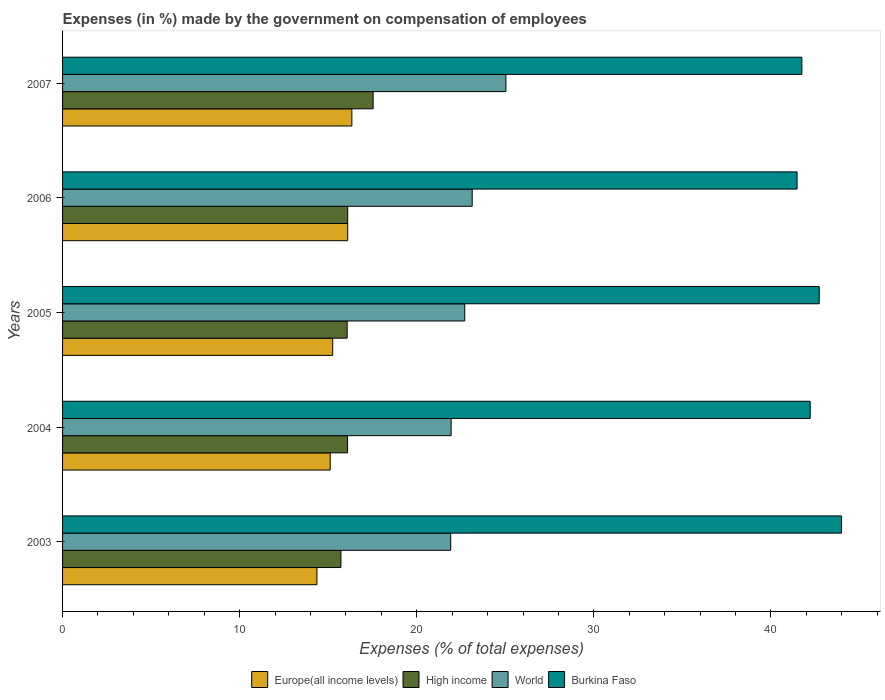Are the number of bars per tick equal to the number of legend labels?
Give a very brief answer. Yes. How many bars are there on the 4th tick from the bottom?
Your response must be concise. 4. What is the percentage of expenses made by the government on compensation of employees in Burkina Faso in 2006?
Provide a short and direct response. 41.47. Across all years, what is the maximum percentage of expenses made by the government on compensation of employees in Europe(all income levels)?
Keep it short and to the point. 16.34. Across all years, what is the minimum percentage of expenses made by the government on compensation of employees in High income?
Provide a short and direct response. 15.72. What is the total percentage of expenses made by the government on compensation of employees in Burkina Faso in the graph?
Provide a succinct answer. 212.14. What is the difference between the percentage of expenses made by the government on compensation of employees in High income in 2005 and that in 2007?
Provide a succinct answer. -1.47. What is the difference between the percentage of expenses made by the government on compensation of employees in High income in 2005 and the percentage of expenses made by the government on compensation of employees in Europe(all income levels) in 2007?
Offer a very short reply. -0.27. What is the average percentage of expenses made by the government on compensation of employees in World per year?
Offer a very short reply. 22.94. In the year 2003, what is the difference between the percentage of expenses made by the government on compensation of employees in Europe(all income levels) and percentage of expenses made by the government on compensation of employees in World?
Provide a succinct answer. -7.55. What is the ratio of the percentage of expenses made by the government on compensation of employees in Burkina Faso in 2003 to that in 2006?
Offer a terse response. 1.06. What is the difference between the highest and the second highest percentage of expenses made by the government on compensation of employees in Europe(all income levels)?
Your answer should be very brief. 0.24. What is the difference between the highest and the lowest percentage of expenses made by the government on compensation of employees in Europe(all income levels)?
Your response must be concise. 1.97. What does the 2nd bar from the top in 2006 represents?
Offer a very short reply. World. What does the 2nd bar from the bottom in 2004 represents?
Your answer should be compact. High income. Is it the case that in every year, the sum of the percentage of expenses made by the government on compensation of employees in World and percentage of expenses made by the government on compensation of employees in Burkina Faso is greater than the percentage of expenses made by the government on compensation of employees in High income?
Provide a short and direct response. Yes. How many bars are there?
Offer a terse response. 20. What is the difference between two consecutive major ticks on the X-axis?
Make the answer very short. 10. Are the values on the major ticks of X-axis written in scientific E-notation?
Your answer should be compact. No. Does the graph contain any zero values?
Offer a very short reply. No. Does the graph contain grids?
Offer a very short reply. No. What is the title of the graph?
Your answer should be compact. Expenses (in %) made by the government on compensation of employees. Does "Sudan" appear as one of the legend labels in the graph?
Make the answer very short. No. What is the label or title of the X-axis?
Your response must be concise. Expenses (% of total expenses). What is the label or title of the Y-axis?
Ensure brevity in your answer.  Years. What is the Expenses (% of total expenses) in Europe(all income levels) in 2003?
Your answer should be compact. 14.36. What is the Expenses (% of total expenses) in High income in 2003?
Your answer should be very brief. 15.72. What is the Expenses (% of total expenses) of World in 2003?
Your answer should be compact. 21.92. What is the Expenses (% of total expenses) in Burkina Faso in 2003?
Offer a very short reply. 43.98. What is the Expenses (% of total expenses) of Europe(all income levels) in 2004?
Keep it short and to the point. 15.11. What is the Expenses (% of total expenses) in High income in 2004?
Provide a succinct answer. 16.09. What is the Expenses (% of total expenses) in World in 2004?
Offer a very short reply. 21.94. What is the Expenses (% of total expenses) in Burkina Faso in 2004?
Provide a succinct answer. 42.21. What is the Expenses (% of total expenses) in Europe(all income levels) in 2005?
Provide a short and direct response. 15.25. What is the Expenses (% of total expenses) of High income in 2005?
Offer a very short reply. 16.07. What is the Expenses (% of total expenses) of World in 2005?
Your answer should be very brief. 22.71. What is the Expenses (% of total expenses) in Burkina Faso in 2005?
Keep it short and to the point. 42.72. What is the Expenses (% of total expenses) in Europe(all income levels) in 2006?
Offer a very short reply. 16.1. What is the Expenses (% of total expenses) in High income in 2006?
Provide a succinct answer. 16.1. What is the Expenses (% of total expenses) in World in 2006?
Your answer should be compact. 23.13. What is the Expenses (% of total expenses) in Burkina Faso in 2006?
Give a very brief answer. 41.47. What is the Expenses (% of total expenses) in Europe(all income levels) in 2007?
Give a very brief answer. 16.34. What is the Expenses (% of total expenses) in High income in 2007?
Provide a succinct answer. 17.54. What is the Expenses (% of total expenses) in World in 2007?
Your answer should be very brief. 25.03. What is the Expenses (% of total expenses) in Burkina Faso in 2007?
Offer a very short reply. 41.74. Across all years, what is the maximum Expenses (% of total expenses) of Europe(all income levels)?
Provide a succinct answer. 16.34. Across all years, what is the maximum Expenses (% of total expenses) of High income?
Give a very brief answer. 17.54. Across all years, what is the maximum Expenses (% of total expenses) of World?
Ensure brevity in your answer.  25.03. Across all years, what is the maximum Expenses (% of total expenses) of Burkina Faso?
Make the answer very short. 43.98. Across all years, what is the minimum Expenses (% of total expenses) of Europe(all income levels)?
Offer a very short reply. 14.36. Across all years, what is the minimum Expenses (% of total expenses) in High income?
Your answer should be very brief. 15.72. Across all years, what is the minimum Expenses (% of total expenses) in World?
Offer a terse response. 21.92. Across all years, what is the minimum Expenses (% of total expenses) of Burkina Faso?
Keep it short and to the point. 41.47. What is the total Expenses (% of total expenses) of Europe(all income levels) in the graph?
Ensure brevity in your answer.  77.16. What is the total Expenses (% of total expenses) of High income in the graph?
Your answer should be very brief. 81.52. What is the total Expenses (% of total expenses) in World in the graph?
Ensure brevity in your answer.  114.72. What is the total Expenses (% of total expenses) in Burkina Faso in the graph?
Offer a very short reply. 212.14. What is the difference between the Expenses (% of total expenses) of Europe(all income levels) in 2003 and that in 2004?
Offer a very short reply. -0.75. What is the difference between the Expenses (% of total expenses) in High income in 2003 and that in 2004?
Your answer should be very brief. -0.37. What is the difference between the Expenses (% of total expenses) in World in 2003 and that in 2004?
Ensure brevity in your answer.  -0.02. What is the difference between the Expenses (% of total expenses) in Burkina Faso in 2003 and that in 2004?
Offer a terse response. 1.77. What is the difference between the Expenses (% of total expenses) of Europe(all income levels) in 2003 and that in 2005?
Offer a very short reply. -0.89. What is the difference between the Expenses (% of total expenses) of High income in 2003 and that in 2005?
Ensure brevity in your answer.  -0.35. What is the difference between the Expenses (% of total expenses) of World in 2003 and that in 2005?
Make the answer very short. -0.79. What is the difference between the Expenses (% of total expenses) of Burkina Faso in 2003 and that in 2005?
Provide a short and direct response. 1.26. What is the difference between the Expenses (% of total expenses) of Europe(all income levels) in 2003 and that in 2006?
Your answer should be compact. -1.74. What is the difference between the Expenses (% of total expenses) in High income in 2003 and that in 2006?
Give a very brief answer. -0.38. What is the difference between the Expenses (% of total expenses) of World in 2003 and that in 2006?
Make the answer very short. -1.21. What is the difference between the Expenses (% of total expenses) of Burkina Faso in 2003 and that in 2006?
Keep it short and to the point. 2.51. What is the difference between the Expenses (% of total expenses) of Europe(all income levels) in 2003 and that in 2007?
Make the answer very short. -1.97. What is the difference between the Expenses (% of total expenses) of High income in 2003 and that in 2007?
Your answer should be compact. -1.82. What is the difference between the Expenses (% of total expenses) in World in 2003 and that in 2007?
Your answer should be very brief. -3.12. What is the difference between the Expenses (% of total expenses) in Burkina Faso in 2003 and that in 2007?
Your answer should be very brief. 2.24. What is the difference between the Expenses (% of total expenses) of Europe(all income levels) in 2004 and that in 2005?
Your response must be concise. -0.14. What is the difference between the Expenses (% of total expenses) in High income in 2004 and that in 2005?
Your answer should be compact. 0.02. What is the difference between the Expenses (% of total expenses) in World in 2004 and that in 2005?
Your answer should be compact. -0.77. What is the difference between the Expenses (% of total expenses) in Burkina Faso in 2004 and that in 2005?
Your answer should be compact. -0.51. What is the difference between the Expenses (% of total expenses) in Europe(all income levels) in 2004 and that in 2006?
Keep it short and to the point. -0.99. What is the difference between the Expenses (% of total expenses) in High income in 2004 and that in 2006?
Provide a succinct answer. -0.01. What is the difference between the Expenses (% of total expenses) of World in 2004 and that in 2006?
Offer a terse response. -1.19. What is the difference between the Expenses (% of total expenses) in Burkina Faso in 2004 and that in 2006?
Your response must be concise. 0.74. What is the difference between the Expenses (% of total expenses) of Europe(all income levels) in 2004 and that in 2007?
Offer a terse response. -1.22. What is the difference between the Expenses (% of total expenses) of High income in 2004 and that in 2007?
Offer a terse response. -1.44. What is the difference between the Expenses (% of total expenses) in World in 2004 and that in 2007?
Your answer should be compact. -3.09. What is the difference between the Expenses (% of total expenses) in Burkina Faso in 2004 and that in 2007?
Give a very brief answer. 0.47. What is the difference between the Expenses (% of total expenses) in Europe(all income levels) in 2005 and that in 2006?
Keep it short and to the point. -0.85. What is the difference between the Expenses (% of total expenses) in High income in 2005 and that in 2006?
Keep it short and to the point. -0.03. What is the difference between the Expenses (% of total expenses) of World in 2005 and that in 2006?
Make the answer very short. -0.42. What is the difference between the Expenses (% of total expenses) of Burkina Faso in 2005 and that in 2006?
Offer a very short reply. 1.25. What is the difference between the Expenses (% of total expenses) of Europe(all income levels) in 2005 and that in 2007?
Offer a very short reply. -1.08. What is the difference between the Expenses (% of total expenses) of High income in 2005 and that in 2007?
Keep it short and to the point. -1.47. What is the difference between the Expenses (% of total expenses) of World in 2005 and that in 2007?
Your response must be concise. -2.33. What is the difference between the Expenses (% of total expenses) of Burkina Faso in 2005 and that in 2007?
Provide a short and direct response. 0.98. What is the difference between the Expenses (% of total expenses) in Europe(all income levels) in 2006 and that in 2007?
Keep it short and to the point. -0.24. What is the difference between the Expenses (% of total expenses) in High income in 2006 and that in 2007?
Your answer should be compact. -1.44. What is the difference between the Expenses (% of total expenses) of World in 2006 and that in 2007?
Provide a short and direct response. -1.9. What is the difference between the Expenses (% of total expenses) of Burkina Faso in 2006 and that in 2007?
Your response must be concise. -0.27. What is the difference between the Expenses (% of total expenses) of Europe(all income levels) in 2003 and the Expenses (% of total expenses) of High income in 2004?
Your answer should be very brief. -1.73. What is the difference between the Expenses (% of total expenses) in Europe(all income levels) in 2003 and the Expenses (% of total expenses) in World in 2004?
Make the answer very short. -7.58. What is the difference between the Expenses (% of total expenses) of Europe(all income levels) in 2003 and the Expenses (% of total expenses) of Burkina Faso in 2004?
Offer a very short reply. -27.85. What is the difference between the Expenses (% of total expenses) in High income in 2003 and the Expenses (% of total expenses) in World in 2004?
Ensure brevity in your answer.  -6.22. What is the difference between the Expenses (% of total expenses) in High income in 2003 and the Expenses (% of total expenses) in Burkina Faso in 2004?
Offer a very short reply. -26.5. What is the difference between the Expenses (% of total expenses) of World in 2003 and the Expenses (% of total expenses) of Burkina Faso in 2004?
Provide a short and direct response. -20.3. What is the difference between the Expenses (% of total expenses) in Europe(all income levels) in 2003 and the Expenses (% of total expenses) in High income in 2005?
Offer a terse response. -1.71. What is the difference between the Expenses (% of total expenses) of Europe(all income levels) in 2003 and the Expenses (% of total expenses) of World in 2005?
Provide a short and direct response. -8.35. What is the difference between the Expenses (% of total expenses) of Europe(all income levels) in 2003 and the Expenses (% of total expenses) of Burkina Faso in 2005?
Your answer should be compact. -28.36. What is the difference between the Expenses (% of total expenses) of High income in 2003 and the Expenses (% of total expenses) of World in 2005?
Offer a terse response. -6.99. What is the difference between the Expenses (% of total expenses) in High income in 2003 and the Expenses (% of total expenses) in Burkina Faso in 2005?
Your answer should be very brief. -27.01. What is the difference between the Expenses (% of total expenses) of World in 2003 and the Expenses (% of total expenses) of Burkina Faso in 2005?
Ensure brevity in your answer.  -20.81. What is the difference between the Expenses (% of total expenses) of Europe(all income levels) in 2003 and the Expenses (% of total expenses) of High income in 2006?
Provide a succinct answer. -1.74. What is the difference between the Expenses (% of total expenses) in Europe(all income levels) in 2003 and the Expenses (% of total expenses) in World in 2006?
Your response must be concise. -8.77. What is the difference between the Expenses (% of total expenses) in Europe(all income levels) in 2003 and the Expenses (% of total expenses) in Burkina Faso in 2006?
Provide a succinct answer. -27.11. What is the difference between the Expenses (% of total expenses) in High income in 2003 and the Expenses (% of total expenses) in World in 2006?
Offer a terse response. -7.41. What is the difference between the Expenses (% of total expenses) of High income in 2003 and the Expenses (% of total expenses) of Burkina Faso in 2006?
Make the answer very short. -25.75. What is the difference between the Expenses (% of total expenses) in World in 2003 and the Expenses (% of total expenses) in Burkina Faso in 2006?
Offer a terse response. -19.56. What is the difference between the Expenses (% of total expenses) in Europe(all income levels) in 2003 and the Expenses (% of total expenses) in High income in 2007?
Keep it short and to the point. -3.17. What is the difference between the Expenses (% of total expenses) in Europe(all income levels) in 2003 and the Expenses (% of total expenses) in World in 2007?
Your answer should be very brief. -10.67. What is the difference between the Expenses (% of total expenses) of Europe(all income levels) in 2003 and the Expenses (% of total expenses) of Burkina Faso in 2007?
Your answer should be compact. -27.38. What is the difference between the Expenses (% of total expenses) in High income in 2003 and the Expenses (% of total expenses) in World in 2007?
Ensure brevity in your answer.  -9.31. What is the difference between the Expenses (% of total expenses) of High income in 2003 and the Expenses (% of total expenses) of Burkina Faso in 2007?
Your response must be concise. -26.02. What is the difference between the Expenses (% of total expenses) in World in 2003 and the Expenses (% of total expenses) in Burkina Faso in 2007?
Provide a short and direct response. -19.83. What is the difference between the Expenses (% of total expenses) in Europe(all income levels) in 2004 and the Expenses (% of total expenses) in High income in 2005?
Offer a very short reply. -0.96. What is the difference between the Expenses (% of total expenses) of Europe(all income levels) in 2004 and the Expenses (% of total expenses) of World in 2005?
Offer a terse response. -7.6. What is the difference between the Expenses (% of total expenses) in Europe(all income levels) in 2004 and the Expenses (% of total expenses) in Burkina Faso in 2005?
Your response must be concise. -27.61. What is the difference between the Expenses (% of total expenses) in High income in 2004 and the Expenses (% of total expenses) in World in 2005?
Ensure brevity in your answer.  -6.61. What is the difference between the Expenses (% of total expenses) in High income in 2004 and the Expenses (% of total expenses) in Burkina Faso in 2005?
Offer a very short reply. -26.63. What is the difference between the Expenses (% of total expenses) in World in 2004 and the Expenses (% of total expenses) in Burkina Faso in 2005?
Keep it short and to the point. -20.78. What is the difference between the Expenses (% of total expenses) in Europe(all income levels) in 2004 and the Expenses (% of total expenses) in High income in 2006?
Give a very brief answer. -0.99. What is the difference between the Expenses (% of total expenses) in Europe(all income levels) in 2004 and the Expenses (% of total expenses) in World in 2006?
Keep it short and to the point. -8.02. What is the difference between the Expenses (% of total expenses) of Europe(all income levels) in 2004 and the Expenses (% of total expenses) of Burkina Faso in 2006?
Offer a terse response. -26.36. What is the difference between the Expenses (% of total expenses) of High income in 2004 and the Expenses (% of total expenses) of World in 2006?
Your answer should be very brief. -7.04. What is the difference between the Expenses (% of total expenses) of High income in 2004 and the Expenses (% of total expenses) of Burkina Faso in 2006?
Your answer should be very brief. -25.38. What is the difference between the Expenses (% of total expenses) in World in 2004 and the Expenses (% of total expenses) in Burkina Faso in 2006?
Keep it short and to the point. -19.53. What is the difference between the Expenses (% of total expenses) of Europe(all income levels) in 2004 and the Expenses (% of total expenses) of High income in 2007?
Provide a short and direct response. -2.42. What is the difference between the Expenses (% of total expenses) of Europe(all income levels) in 2004 and the Expenses (% of total expenses) of World in 2007?
Ensure brevity in your answer.  -9.92. What is the difference between the Expenses (% of total expenses) in Europe(all income levels) in 2004 and the Expenses (% of total expenses) in Burkina Faso in 2007?
Offer a very short reply. -26.63. What is the difference between the Expenses (% of total expenses) in High income in 2004 and the Expenses (% of total expenses) in World in 2007?
Your response must be concise. -8.94. What is the difference between the Expenses (% of total expenses) in High income in 2004 and the Expenses (% of total expenses) in Burkina Faso in 2007?
Your answer should be compact. -25.65. What is the difference between the Expenses (% of total expenses) of World in 2004 and the Expenses (% of total expenses) of Burkina Faso in 2007?
Ensure brevity in your answer.  -19.8. What is the difference between the Expenses (% of total expenses) of Europe(all income levels) in 2005 and the Expenses (% of total expenses) of High income in 2006?
Ensure brevity in your answer.  -0.85. What is the difference between the Expenses (% of total expenses) of Europe(all income levels) in 2005 and the Expenses (% of total expenses) of World in 2006?
Provide a short and direct response. -7.88. What is the difference between the Expenses (% of total expenses) in Europe(all income levels) in 2005 and the Expenses (% of total expenses) in Burkina Faso in 2006?
Your answer should be very brief. -26.22. What is the difference between the Expenses (% of total expenses) of High income in 2005 and the Expenses (% of total expenses) of World in 2006?
Your response must be concise. -7.06. What is the difference between the Expenses (% of total expenses) in High income in 2005 and the Expenses (% of total expenses) in Burkina Faso in 2006?
Give a very brief answer. -25.4. What is the difference between the Expenses (% of total expenses) of World in 2005 and the Expenses (% of total expenses) of Burkina Faso in 2006?
Give a very brief answer. -18.76. What is the difference between the Expenses (% of total expenses) of Europe(all income levels) in 2005 and the Expenses (% of total expenses) of High income in 2007?
Your answer should be compact. -2.28. What is the difference between the Expenses (% of total expenses) in Europe(all income levels) in 2005 and the Expenses (% of total expenses) in World in 2007?
Offer a terse response. -9.78. What is the difference between the Expenses (% of total expenses) of Europe(all income levels) in 2005 and the Expenses (% of total expenses) of Burkina Faso in 2007?
Provide a succinct answer. -26.49. What is the difference between the Expenses (% of total expenses) of High income in 2005 and the Expenses (% of total expenses) of World in 2007?
Your response must be concise. -8.96. What is the difference between the Expenses (% of total expenses) of High income in 2005 and the Expenses (% of total expenses) of Burkina Faso in 2007?
Keep it short and to the point. -25.67. What is the difference between the Expenses (% of total expenses) in World in 2005 and the Expenses (% of total expenses) in Burkina Faso in 2007?
Keep it short and to the point. -19.03. What is the difference between the Expenses (% of total expenses) in Europe(all income levels) in 2006 and the Expenses (% of total expenses) in High income in 2007?
Your answer should be very brief. -1.44. What is the difference between the Expenses (% of total expenses) of Europe(all income levels) in 2006 and the Expenses (% of total expenses) of World in 2007?
Your answer should be compact. -8.93. What is the difference between the Expenses (% of total expenses) in Europe(all income levels) in 2006 and the Expenses (% of total expenses) in Burkina Faso in 2007?
Give a very brief answer. -25.64. What is the difference between the Expenses (% of total expenses) of High income in 2006 and the Expenses (% of total expenses) of World in 2007?
Provide a short and direct response. -8.93. What is the difference between the Expenses (% of total expenses) of High income in 2006 and the Expenses (% of total expenses) of Burkina Faso in 2007?
Ensure brevity in your answer.  -25.64. What is the difference between the Expenses (% of total expenses) in World in 2006 and the Expenses (% of total expenses) in Burkina Faso in 2007?
Keep it short and to the point. -18.61. What is the average Expenses (% of total expenses) in Europe(all income levels) per year?
Your response must be concise. 15.43. What is the average Expenses (% of total expenses) of High income per year?
Provide a succinct answer. 16.3. What is the average Expenses (% of total expenses) in World per year?
Give a very brief answer. 22.94. What is the average Expenses (% of total expenses) of Burkina Faso per year?
Ensure brevity in your answer.  42.43. In the year 2003, what is the difference between the Expenses (% of total expenses) of Europe(all income levels) and Expenses (% of total expenses) of High income?
Offer a terse response. -1.36. In the year 2003, what is the difference between the Expenses (% of total expenses) of Europe(all income levels) and Expenses (% of total expenses) of World?
Your answer should be compact. -7.55. In the year 2003, what is the difference between the Expenses (% of total expenses) of Europe(all income levels) and Expenses (% of total expenses) of Burkina Faso?
Your answer should be compact. -29.62. In the year 2003, what is the difference between the Expenses (% of total expenses) in High income and Expenses (% of total expenses) in World?
Give a very brief answer. -6.2. In the year 2003, what is the difference between the Expenses (% of total expenses) of High income and Expenses (% of total expenses) of Burkina Faso?
Keep it short and to the point. -28.27. In the year 2003, what is the difference between the Expenses (% of total expenses) in World and Expenses (% of total expenses) in Burkina Faso?
Offer a terse response. -22.07. In the year 2004, what is the difference between the Expenses (% of total expenses) in Europe(all income levels) and Expenses (% of total expenses) in High income?
Ensure brevity in your answer.  -0.98. In the year 2004, what is the difference between the Expenses (% of total expenses) in Europe(all income levels) and Expenses (% of total expenses) in World?
Make the answer very short. -6.83. In the year 2004, what is the difference between the Expenses (% of total expenses) of Europe(all income levels) and Expenses (% of total expenses) of Burkina Faso?
Make the answer very short. -27.1. In the year 2004, what is the difference between the Expenses (% of total expenses) of High income and Expenses (% of total expenses) of World?
Make the answer very short. -5.85. In the year 2004, what is the difference between the Expenses (% of total expenses) of High income and Expenses (% of total expenses) of Burkina Faso?
Your answer should be very brief. -26.12. In the year 2004, what is the difference between the Expenses (% of total expenses) in World and Expenses (% of total expenses) in Burkina Faso?
Offer a terse response. -20.27. In the year 2005, what is the difference between the Expenses (% of total expenses) in Europe(all income levels) and Expenses (% of total expenses) in High income?
Offer a very short reply. -0.82. In the year 2005, what is the difference between the Expenses (% of total expenses) of Europe(all income levels) and Expenses (% of total expenses) of World?
Offer a terse response. -7.45. In the year 2005, what is the difference between the Expenses (% of total expenses) of Europe(all income levels) and Expenses (% of total expenses) of Burkina Faso?
Your answer should be compact. -27.47. In the year 2005, what is the difference between the Expenses (% of total expenses) of High income and Expenses (% of total expenses) of World?
Offer a very short reply. -6.64. In the year 2005, what is the difference between the Expenses (% of total expenses) in High income and Expenses (% of total expenses) in Burkina Faso?
Your answer should be compact. -26.65. In the year 2005, what is the difference between the Expenses (% of total expenses) in World and Expenses (% of total expenses) in Burkina Faso?
Your response must be concise. -20.02. In the year 2006, what is the difference between the Expenses (% of total expenses) of Europe(all income levels) and Expenses (% of total expenses) of High income?
Offer a terse response. 0. In the year 2006, what is the difference between the Expenses (% of total expenses) of Europe(all income levels) and Expenses (% of total expenses) of World?
Keep it short and to the point. -7.03. In the year 2006, what is the difference between the Expenses (% of total expenses) in Europe(all income levels) and Expenses (% of total expenses) in Burkina Faso?
Ensure brevity in your answer.  -25.37. In the year 2006, what is the difference between the Expenses (% of total expenses) of High income and Expenses (% of total expenses) of World?
Your answer should be very brief. -7.03. In the year 2006, what is the difference between the Expenses (% of total expenses) in High income and Expenses (% of total expenses) in Burkina Faso?
Offer a terse response. -25.37. In the year 2006, what is the difference between the Expenses (% of total expenses) in World and Expenses (% of total expenses) in Burkina Faso?
Give a very brief answer. -18.34. In the year 2007, what is the difference between the Expenses (% of total expenses) of Europe(all income levels) and Expenses (% of total expenses) of High income?
Your answer should be compact. -1.2. In the year 2007, what is the difference between the Expenses (% of total expenses) in Europe(all income levels) and Expenses (% of total expenses) in World?
Provide a succinct answer. -8.7. In the year 2007, what is the difference between the Expenses (% of total expenses) of Europe(all income levels) and Expenses (% of total expenses) of Burkina Faso?
Keep it short and to the point. -25.41. In the year 2007, what is the difference between the Expenses (% of total expenses) of High income and Expenses (% of total expenses) of World?
Your response must be concise. -7.5. In the year 2007, what is the difference between the Expenses (% of total expenses) in High income and Expenses (% of total expenses) in Burkina Faso?
Your answer should be very brief. -24.21. In the year 2007, what is the difference between the Expenses (% of total expenses) of World and Expenses (% of total expenses) of Burkina Faso?
Give a very brief answer. -16.71. What is the ratio of the Expenses (% of total expenses) of Europe(all income levels) in 2003 to that in 2004?
Give a very brief answer. 0.95. What is the ratio of the Expenses (% of total expenses) in High income in 2003 to that in 2004?
Provide a succinct answer. 0.98. What is the ratio of the Expenses (% of total expenses) in World in 2003 to that in 2004?
Your answer should be compact. 1. What is the ratio of the Expenses (% of total expenses) of Burkina Faso in 2003 to that in 2004?
Make the answer very short. 1.04. What is the ratio of the Expenses (% of total expenses) in Europe(all income levels) in 2003 to that in 2005?
Your answer should be very brief. 0.94. What is the ratio of the Expenses (% of total expenses) in High income in 2003 to that in 2005?
Make the answer very short. 0.98. What is the ratio of the Expenses (% of total expenses) in World in 2003 to that in 2005?
Provide a short and direct response. 0.97. What is the ratio of the Expenses (% of total expenses) of Burkina Faso in 2003 to that in 2005?
Your response must be concise. 1.03. What is the ratio of the Expenses (% of total expenses) of Europe(all income levels) in 2003 to that in 2006?
Your response must be concise. 0.89. What is the ratio of the Expenses (% of total expenses) in High income in 2003 to that in 2006?
Your answer should be very brief. 0.98. What is the ratio of the Expenses (% of total expenses) of World in 2003 to that in 2006?
Provide a succinct answer. 0.95. What is the ratio of the Expenses (% of total expenses) of Burkina Faso in 2003 to that in 2006?
Ensure brevity in your answer.  1.06. What is the ratio of the Expenses (% of total expenses) of Europe(all income levels) in 2003 to that in 2007?
Give a very brief answer. 0.88. What is the ratio of the Expenses (% of total expenses) in High income in 2003 to that in 2007?
Provide a succinct answer. 0.9. What is the ratio of the Expenses (% of total expenses) in World in 2003 to that in 2007?
Make the answer very short. 0.88. What is the ratio of the Expenses (% of total expenses) of Burkina Faso in 2003 to that in 2007?
Your answer should be compact. 1.05. What is the ratio of the Expenses (% of total expenses) in Europe(all income levels) in 2004 to that in 2005?
Offer a very short reply. 0.99. What is the ratio of the Expenses (% of total expenses) in World in 2004 to that in 2005?
Your answer should be compact. 0.97. What is the ratio of the Expenses (% of total expenses) of Europe(all income levels) in 2004 to that in 2006?
Offer a very short reply. 0.94. What is the ratio of the Expenses (% of total expenses) of High income in 2004 to that in 2006?
Your answer should be compact. 1. What is the ratio of the Expenses (% of total expenses) in World in 2004 to that in 2006?
Provide a short and direct response. 0.95. What is the ratio of the Expenses (% of total expenses) in Burkina Faso in 2004 to that in 2006?
Offer a terse response. 1.02. What is the ratio of the Expenses (% of total expenses) of Europe(all income levels) in 2004 to that in 2007?
Keep it short and to the point. 0.93. What is the ratio of the Expenses (% of total expenses) in High income in 2004 to that in 2007?
Your response must be concise. 0.92. What is the ratio of the Expenses (% of total expenses) in World in 2004 to that in 2007?
Offer a terse response. 0.88. What is the ratio of the Expenses (% of total expenses) in Burkina Faso in 2004 to that in 2007?
Make the answer very short. 1.01. What is the ratio of the Expenses (% of total expenses) in Europe(all income levels) in 2005 to that in 2006?
Make the answer very short. 0.95. What is the ratio of the Expenses (% of total expenses) in High income in 2005 to that in 2006?
Ensure brevity in your answer.  1. What is the ratio of the Expenses (% of total expenses) of World in 2005 to that in 2006?
Make the answer very short. 0.98. What is the ratio of the Expenses (% of total expenses) of Burkina Faso in 2005 to that in 2006?
Keep it short and to the point. 1.03. What is the ratio of the Expenses (% of total expenses) in Europe(all income levels) in 2005 to that in 2007?
Make the answer very short. 0.93. What is the ratio of the Expenses (% of total expenses) of High income in 2005 to that in 2007?
Offer a terse response. 0.92. What is the ratio of the Expenses (% of total expenses) in World in 2005 to that in 2007?
Give a very brief answer. 0.91. What is the ratio of the Expenses (% of total expenses) in Burkina Faso in 2005 to that in 2007?
Ensure brevity in your answer.  1.02. What is the ratio of the Expenses (% of total expenses) of Europe(all income levels) in 2006 to that in 2007?
Your answer should be very brief. 0.99. What is the ratio of the Expenses (% of total expenses) of High income in 2006 to that in 2007?
Provide a short and direct response. 0.92. What is the ratio of the Expenses (% of total expenses) of World in 2006 to that in 2007?
Provide a short and direct response. 0.92. What is the difference between the highest and the second highest Expenses (% of total expenses) in Europe(all income levels)?
Give a very brief answer. 0.24. What is the difference between the highest and the second highest Expenses (% of total expenses) in High income?
Offer a terse response. 1.44. What is the difference between the highest and the second highest Expenses (% of total expenses) of World?
Provide a succinct answer. 1.9. What is the difference between the highest and the second highest Expenses (% of total expenses) in Burkina Faso?
Your response must be concise. 1.26. What is the difference between the highest and the lowest Expenses (% of total expenses) of Europe(all income levels)?
Provide a short and direct response. 1.97. What is the difference between the highest and the lowest Expenses (% of total expenses) in High income?
Provide a short and direct response. 1.82. What is the difference between the highest and the lowest Expenses (% of total expenses) in World?
Ensure brevity in your answer.  3.12. What is the difference between the highest and the lowest Expenses (% of total expenses) in Burkina Faso?
Provide a succinct answer. 2.51. 